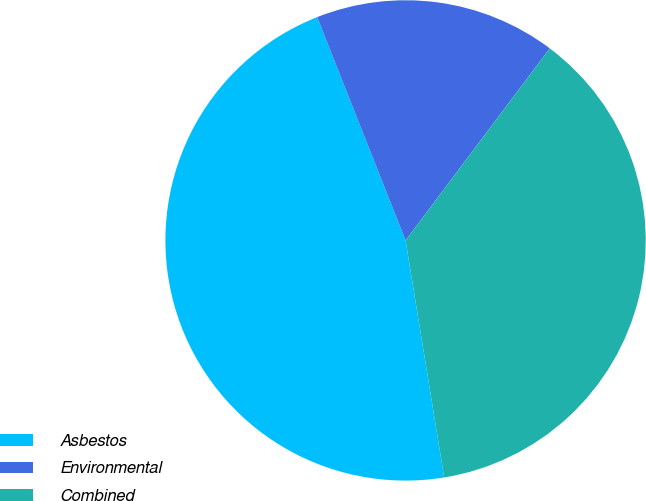<chart> <loc_0><loc_0><loc_500><loc_500><pie_chart><fcel>Asbestos<fcel>Environmental<fcel>Combined<nl><fcel>46.57%<fcel>16.25%<fcel>37.18%<nl></chart> 